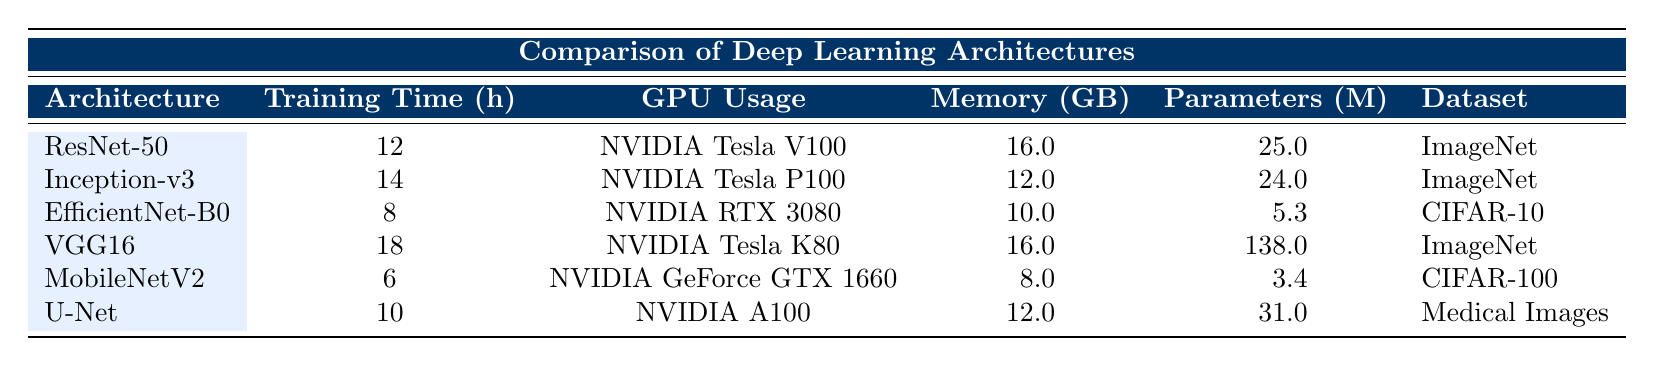What architecture has the longest training time? By examining the "Training Time (h)" column, we can see that VGG16 has the highest value at 18 hours.
Answer: VGG16 Which architecture uses the least amount of memory? Looking at the "Memory (GB)" column, MobileNetV2 uses the least at 8 GB.
Answer: MobileNetV2 What is the total number of parameters across all architectures? The total parameters are calculated by summing the values from the "Parameters (M)" column: 25 + 24 + 5.3 + 138 + 3.4 + 31 = 226.7 million.
Answer: 226.7 million Does U-Net have a higher training time than EfficientNet-B0? Comparing U-Net's training time of 10 hours with EfficientNet-B0's 8 hours, we find that U-Net's time is indeed higher.
Answer: Yes Which GPU is used for the architecture with the second lowest training time? From the "Training Time (h)" column, EfficientNet-B0 (8 hours) is the architecture with the second lowest training time, which uses an NVIDIA RTX 3080.
Answer: NVIDIA RTX 3080 What is the average memory usage of all architectures? The memory usage values are: 16, 12, 10, 16, 8, and 12 GB. The average is calculated as (16 + 12 + 10 + 16 + 8 + 12) / 6 = 12 GB.
Answer: 12 GB Is ImageNet the dataset for all architectures listed? Looking at the "Dataset" column, ImageNet is used for ResNet-50, Inception-v3, and VGG16; however, EfficientNet-B0 uses CIFAR-10 and MobileNetV2 uses CIFAR-100, which confirms that not all architectures use ImageNet.
Answer: No Which architecture has the highest parameters per hour of training? Calculating the parameters per hour of training for each architecture as follows: ResNet-50 (25/12 = 2.083), Inception-v3 (24/14 = 1.714), EfficientNet-B0 (5.3/8 = 0.6625), VGG16 (138/18 = 7.6667), MobileNetV2 (3.4/6 = 0.5667), U-Net (31/10 = 3.1). VGG16 has the highest value at 7.6667.
Answer: VGG16 